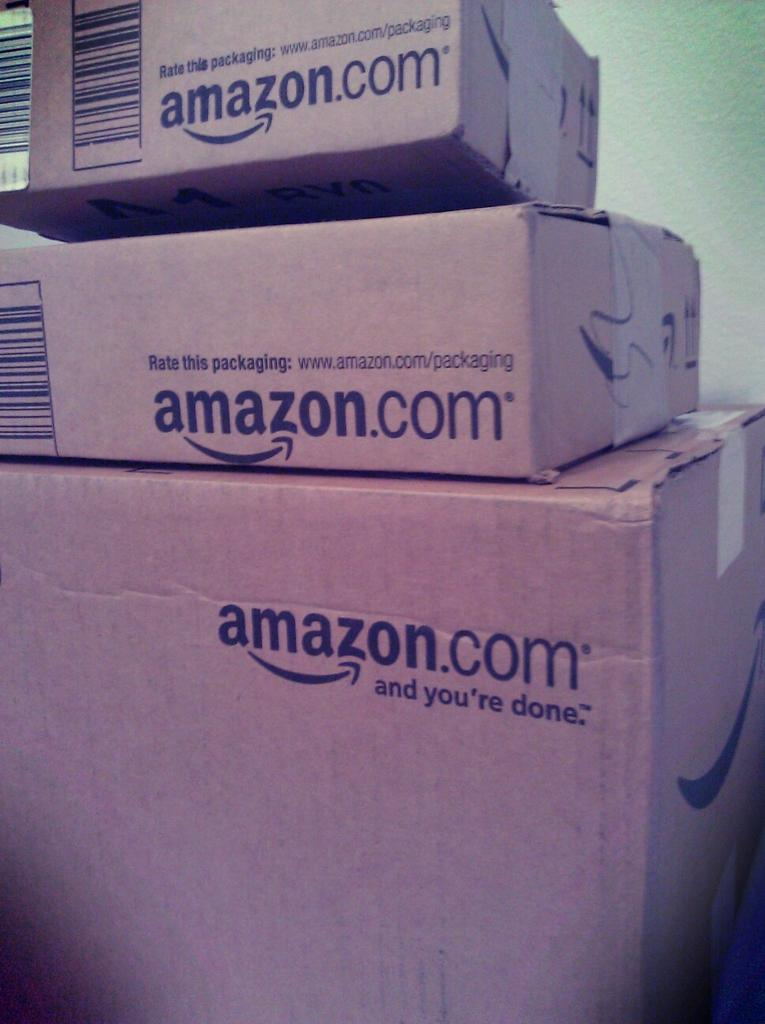<image>
Render a clear and concise summary of the photo. three card board boxes from Amazon.com stacked atop each other 